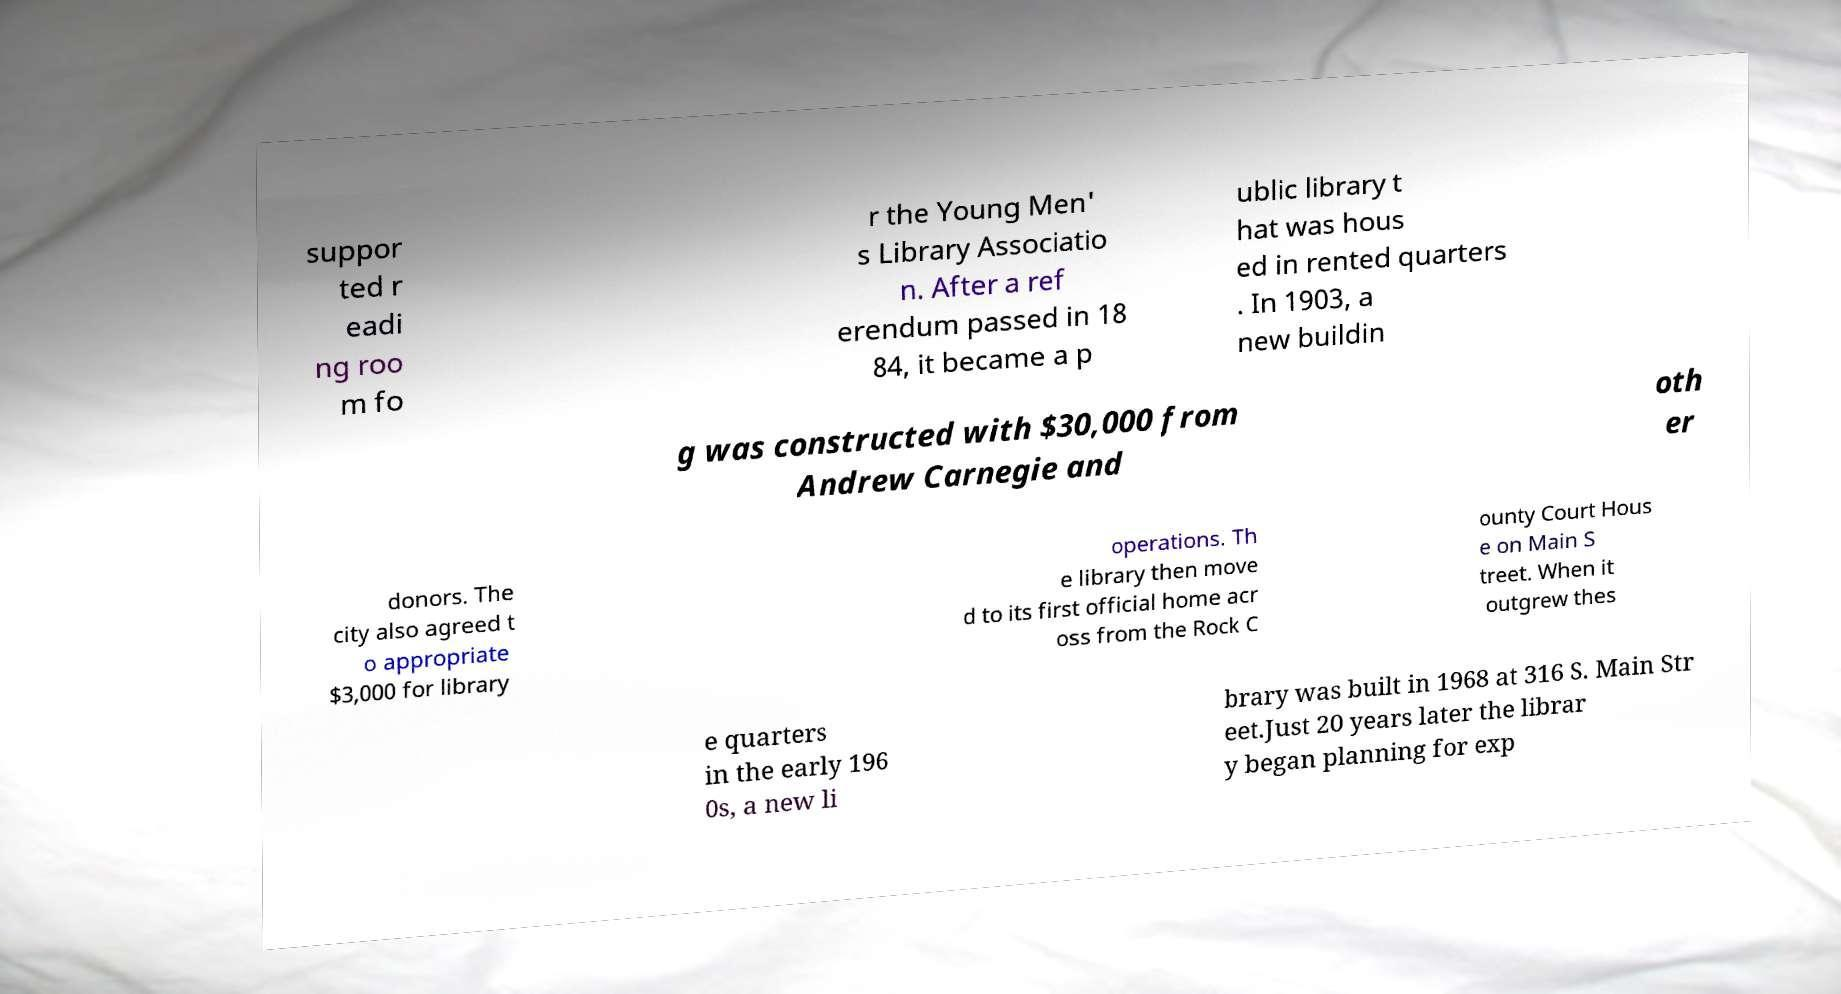I need the written content from this picture converted into text. Can you do that? suppor ted r eadi ng roo m fo r the Young Men' s Library Associatio n. After a ref erendum passed in 18 84, it became a p ublic library t hat was hous ed in rented quarters . In 1903, a new buildin g was constructed with $30,000 from Andrew Carnegie and oth er donors. The city also agreed t o appropriate $3,000 for library operations. Th e library then move d to its first official home acr oss from the Rock C ounty Court Hous e on Main S treet. When it outgrew thes e quarters in the early 196 0s, a new li brary was built in 1968 at 316 S. Main Str eet.Just 20 years later the librar y began planning for exp 